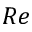<formula> <loc_0><loc_0><loc_500><loc_500>R e</formula> 